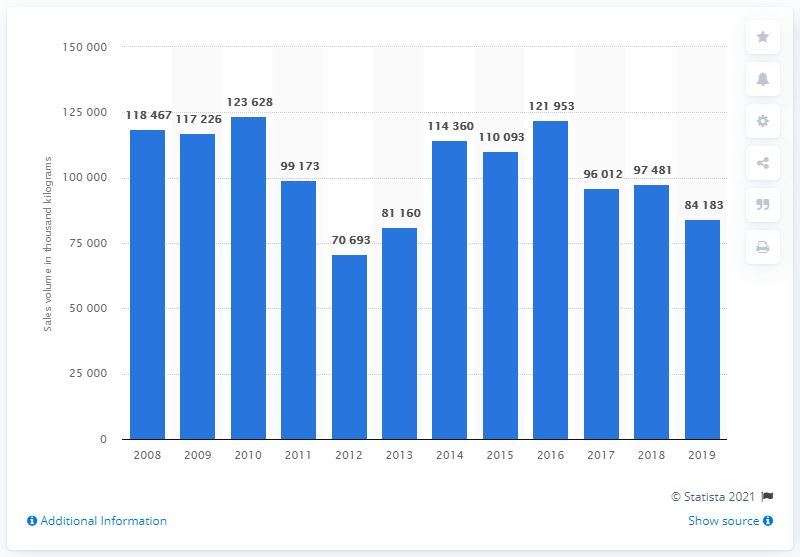List a handful of essential elements in this visual. The sales volume of jams and jellies in 2019 was 84,183 units. 